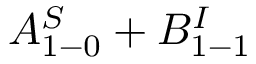<formula> <loc_0><loc_0><loc_500><loc_500>A _ { 1 - 0 } ^ { S } + B _ { 1 - 1 } ^ { I }</formula> 